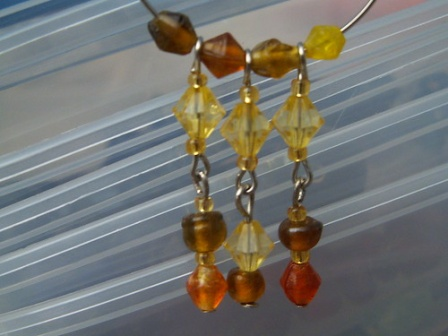What is this photo about? The image features a pair of earrings hanging from a wire, designed with a series of beads strung together by silver chains. Each earring is artfully composed with a varied selection of beads—starting with a small brown bead, followed by a larger yellow bead, and concluding with a smaller red bead at the bottom, creating a vibrant and balanced pattern. The blurred striped background serves to accentuate the earrings, making them the central focus of the image. Their symmetrical design and the elegance of the silver chains add to the overall aesthetic appeal. The photo does not include any additional objects or text, entirely focusing on showcasing the beauty of these handcrafted beaded earrings in a still life setup. 